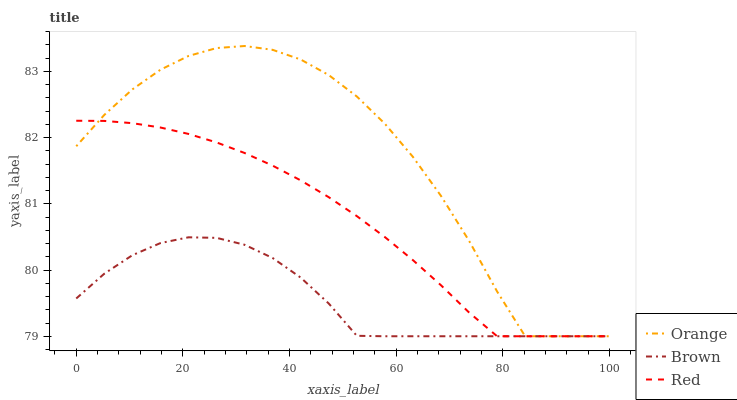Does Brown have the minimum area under the curve?
Answer yes or no. Yes. Does Orange have the maximum area under the curve?
Answer yes or no. Yes. Does Red have the minimum area under the curve?
Answer yes or no. No. Does Red have the maximum area under the curve?
Answer yes or no. No. Is Red the smoothest?
Answer yes or no. Yes. Is Orange the roughest?
Answer yes or no. Yes. Is Brown the smoothest?
Answer yes or no. No. Is Brown the roughest?
Answer yes or no. No. Does Orange have the lowest value?
Answer yes or no. Yes. Does Orange have the highest value?
Answer yes or no. Yes. Does Red have the highest value?
Answer yes or no. No. Does Brown intersect Red?
Answer yes or no. Yes. Is Brown less than Red?
Answer yes or no. No. Is Brown greater than Red?
Answer yes or no. No. 